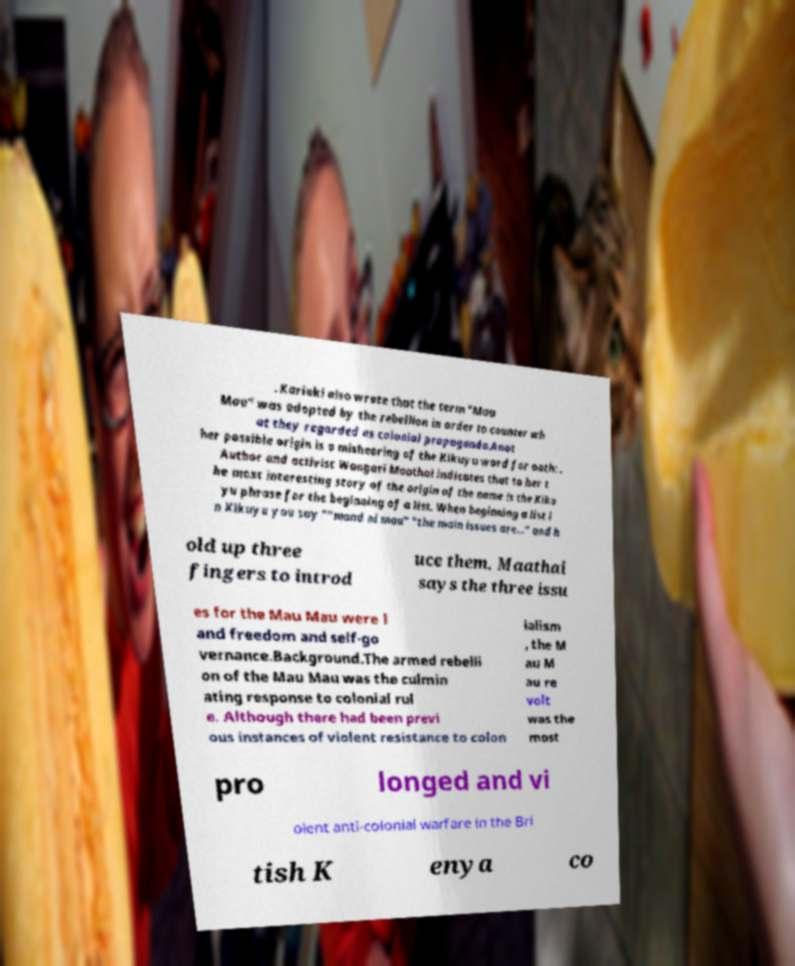Could you extract and type out the text from this image? . Kariuki also wrote that the term "Mau Mau" was adopted by the rebellion in order to counter wh at they regarded as colonial propaganda.Anot her possible origin is a mishearing of the Kikuyu word for oath: . Author and activist Wangari Maathai indicates that to her t he most interesting story of the origin of the name is the Kiku yu phrase for the beginning of a list. When beginning a list i n Kikuyu you say ""mand ni mau" "the main issues are..." and h old up three fingers to introd uce them. Maathai says the three issu es for the Mau Mau were l and freedom and self-go vernance.Background.The armed rebelli on of the Mau Mau was the culmin ating response to colonial rul e. Although there had been previ ous instances of violent resistance to colon ialism , the M au M au re volt was the most pro longed and vi olent anti-colonial warfare in the Bri tish K enya co 